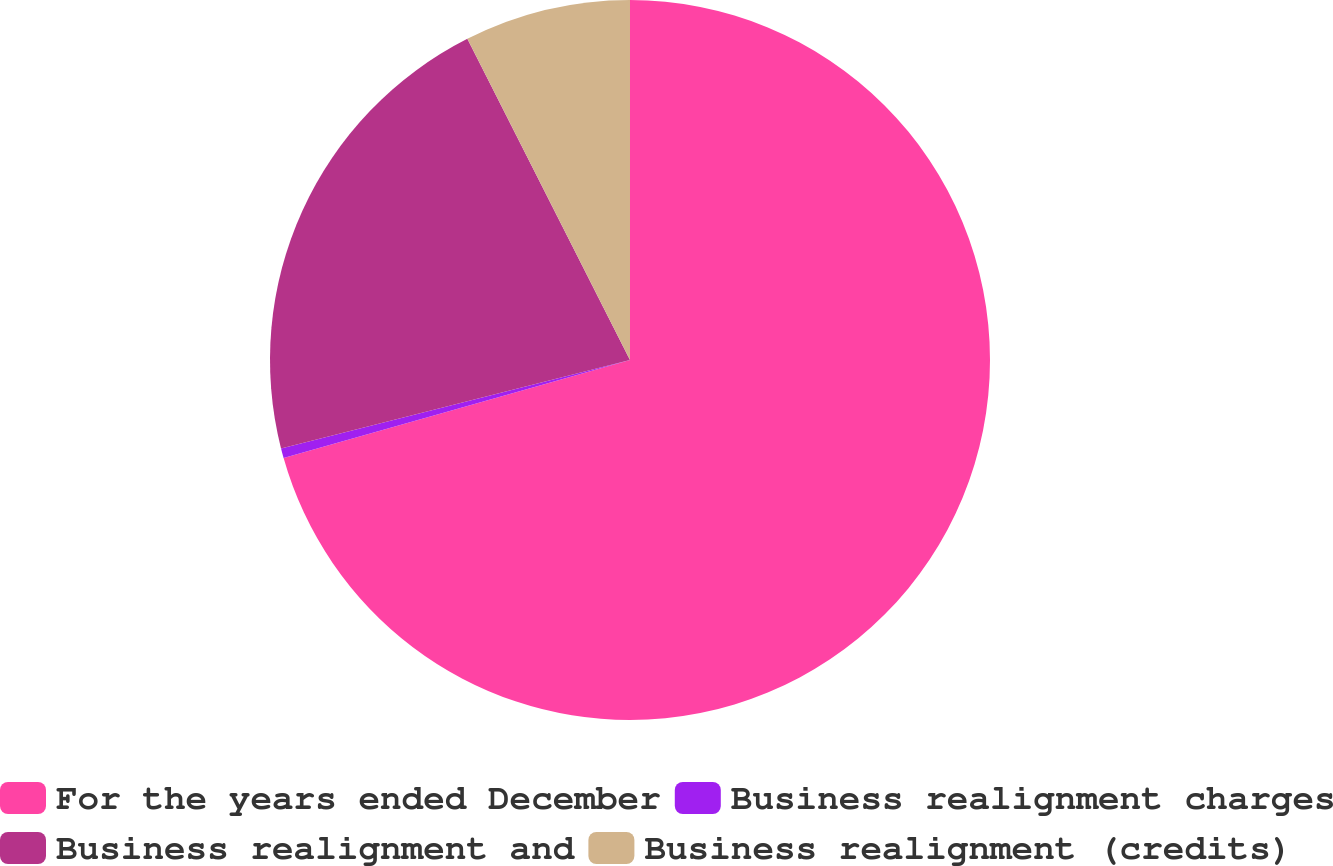Convert chart to OTSL. <chart><loc_0><loc_0><loc_500><loc_500><pie_chart><fcel>For the years ended December<fcel>Business realignment charges<fcel>Business realignment and<fcel>Business realignment (credits)<nl><fcel>70.61%<fcel>0.44%<fcel>21.49%<fcel>7.46%<nl></chart> 